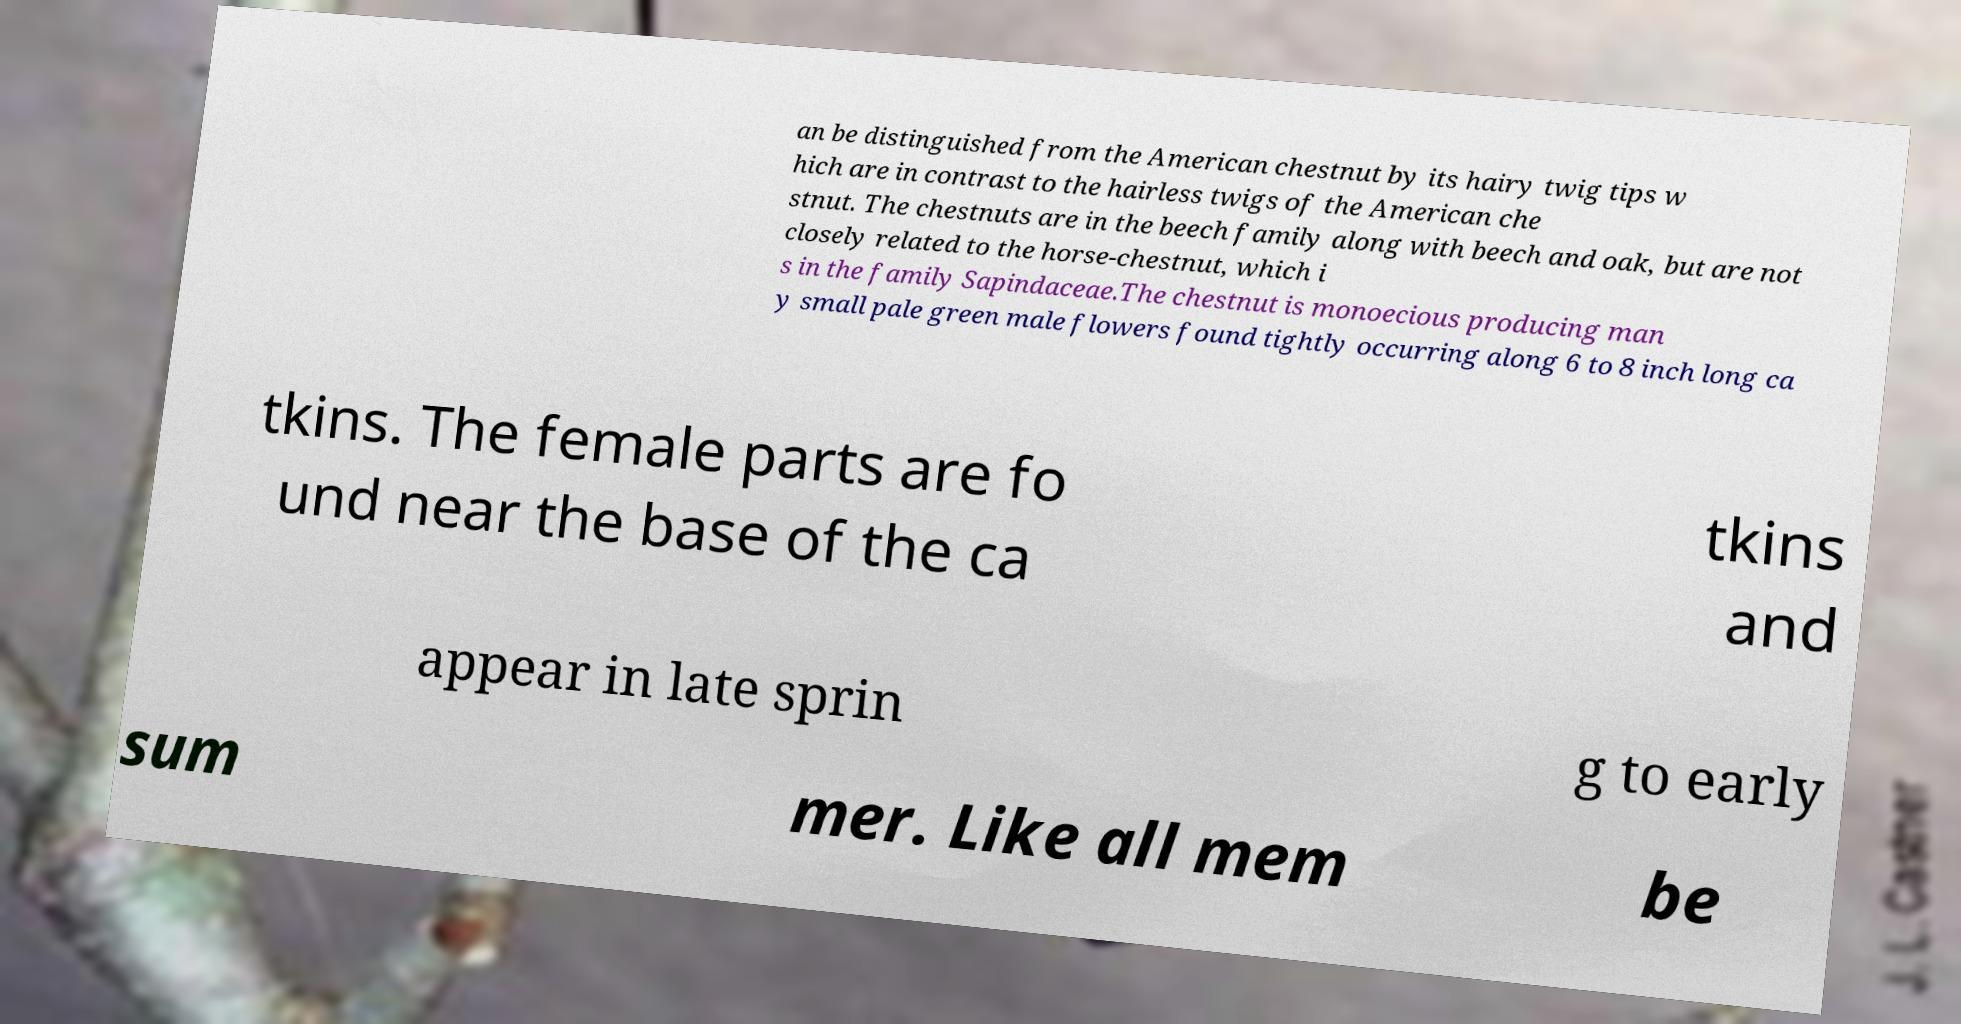Can you read and provide the text displayed in the image?This photo seems to have some interesting text. Can you extract and type it out for me? an be distinguished from the American chestnut by its hairy twig tips w hich are in contrast to the hairless twigs of the American che stnut. The chestnuts are in the beech family along with beech and oak, but are not closely related to the horse-chestnut, which i s in the family Sapindaceae.The chestnut is monoecious producing man y small pale green male flowers found tightly occurring along 6 to 8 inch long ca tkins. The female parts are fo und near the base of the ca tkins and appear in late sprin g to early sum mer. Like all mem be 